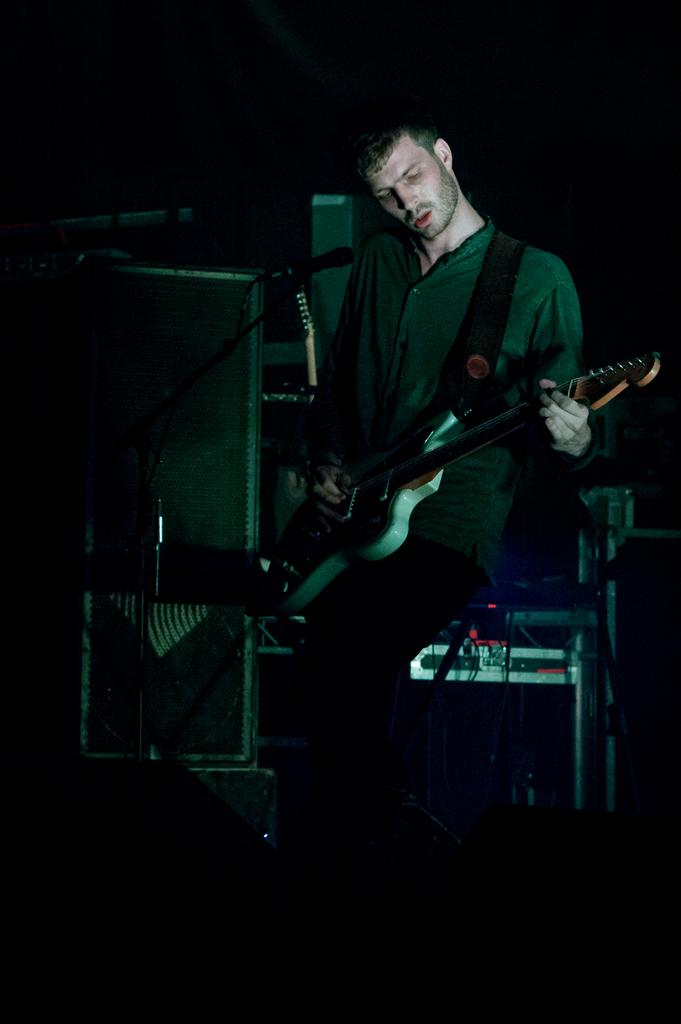What is the main subject of the image? There is a person in the image. What is the person doing in the image? The person is standing and holding a guitar in his hand. What is the person wearing in the image? The person is wearing a green shirt. What object is in front of the person in the image? There is a microphone stand in front of the person. What can be seen behind the person in the image? There are devices visible behind the person. What is the price of the skirt the person is wearing in the image? The person is not wearing a skirt in the image; they are wearing a green shirt. What type of club is the person holding in the image? There is no club present in the image; the person is holding a guitar. 